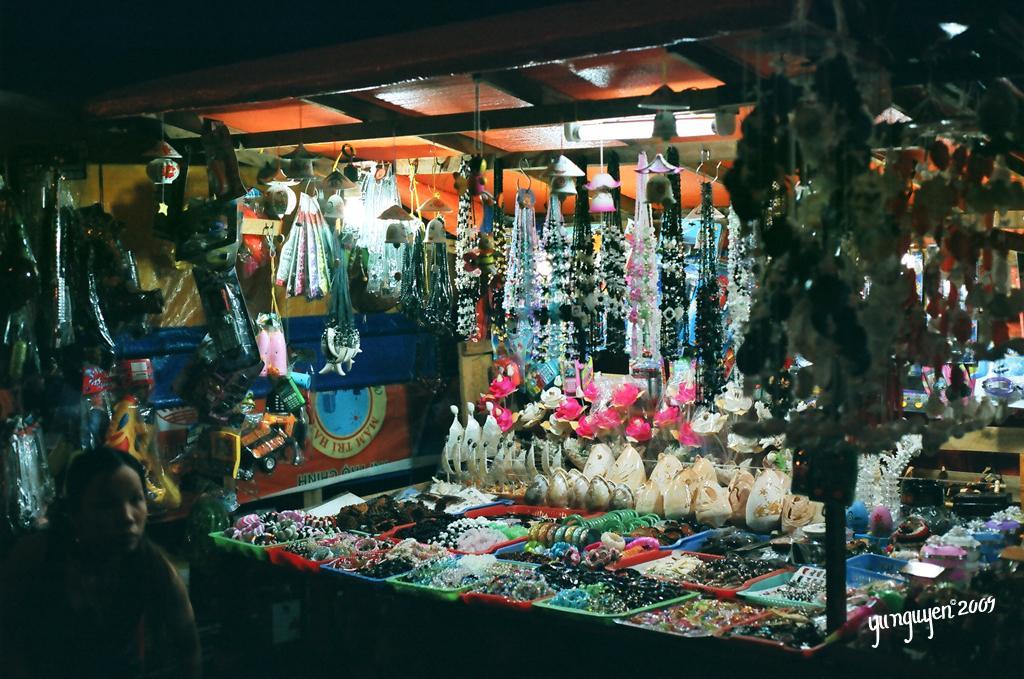How would you summarize this image in a sentence or two? In this image there is a person standing near a shop, in that shop there are few items, on the bottom right there is some text. 